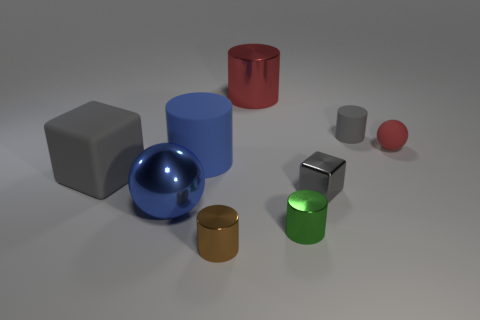Subtract all blue cylinders. How many cylinders are left? 4 Subtract all small rubber cylinders. How many cylinders are left? 4 Subtract 1 cylinders. How many cylinders are left? 4 Subtract all purple cubes. Subtract all red cylinders. How many cubes are left? 2 Add 1 tiny brown spheres. How many objects exist? 10 Subtract all cubes. How many objects are left? 7 Add 2 cubes. How many cubes exist? 4 Subtract 1 red cylinders. How many objects are left? 8 Subtract all purple matte blocks. Subtract all tiny rubber balls. How many objects are left? 8 Add 1 big metallic cylinders. How many big metallic cylinders are left? 2 